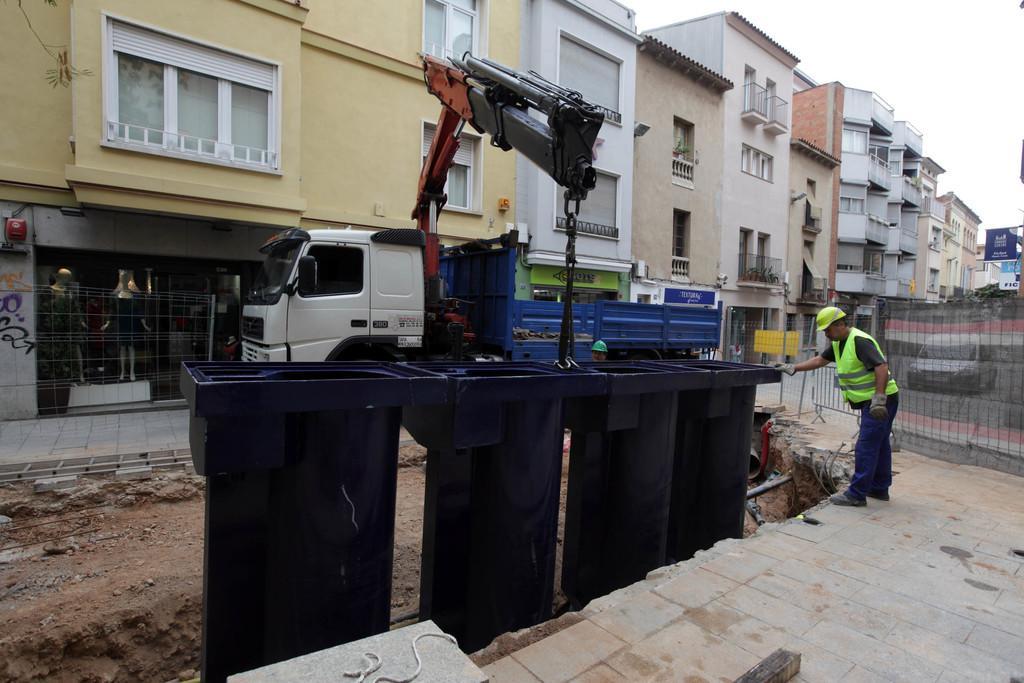Please provide a concise description of this image. In this picture there is a man standing and we can see bins, vehicles on the road, fence, crane on a truck, boards and buildings. In the background of the image we can see the sky. 